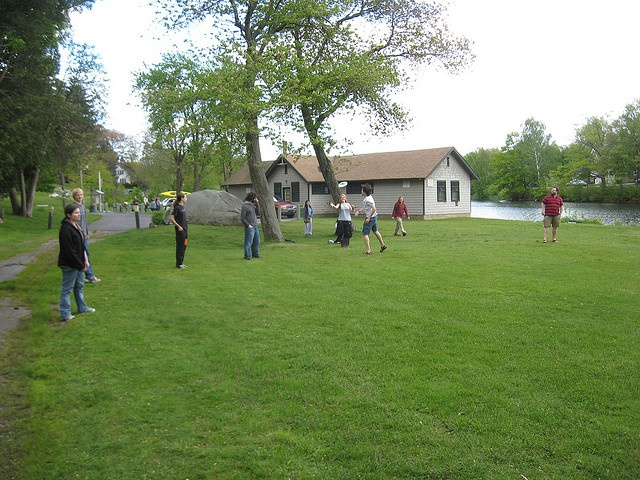Describe the objects in this image and their specific colors. I can see people in black, blue, gray, and darkgreen tones, people in black, gray, blue, and darkblue tones, people in black, gray, and darkgreen tones, people in black, gray, darkgray, and white tones, and people in black, gray, olive, and maroon tones in this image. 